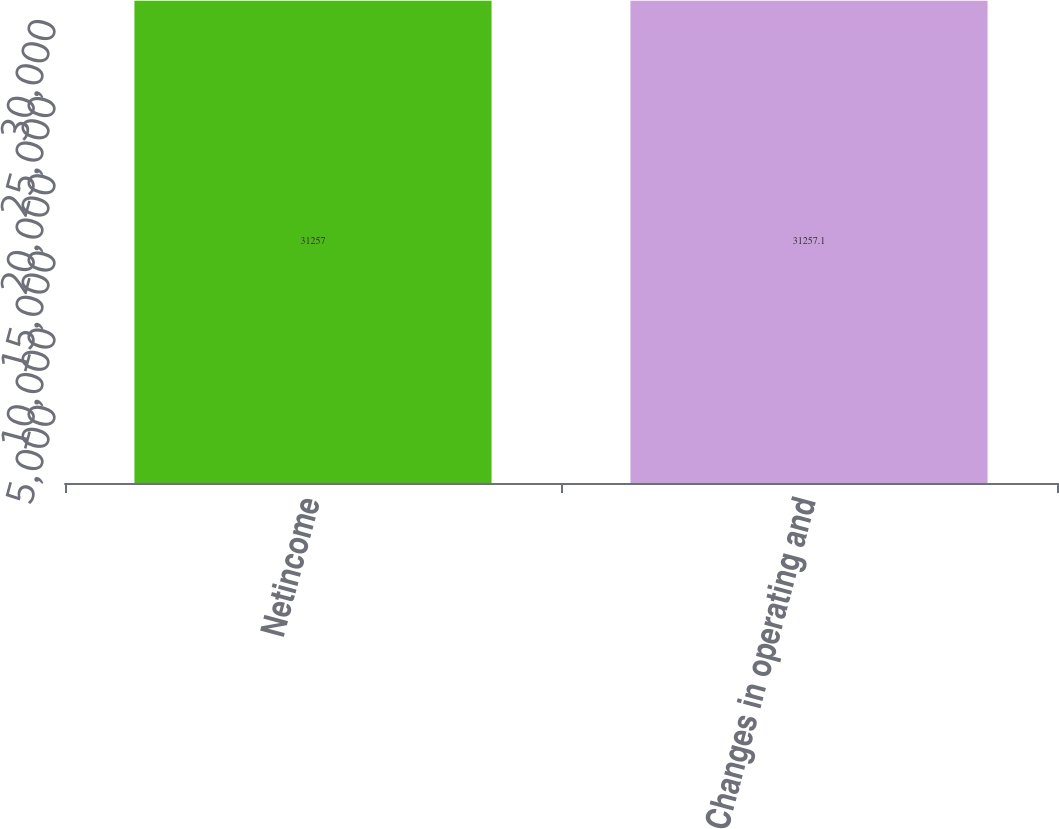Convert chart to OTSL. <chart><loc_0><loc_0><loc_500><loc_500><bar_chart><fcel>Netincome<fcel>Changes in operating and<nl><fcel>31257<fcel>31257.1<nl></chart> 